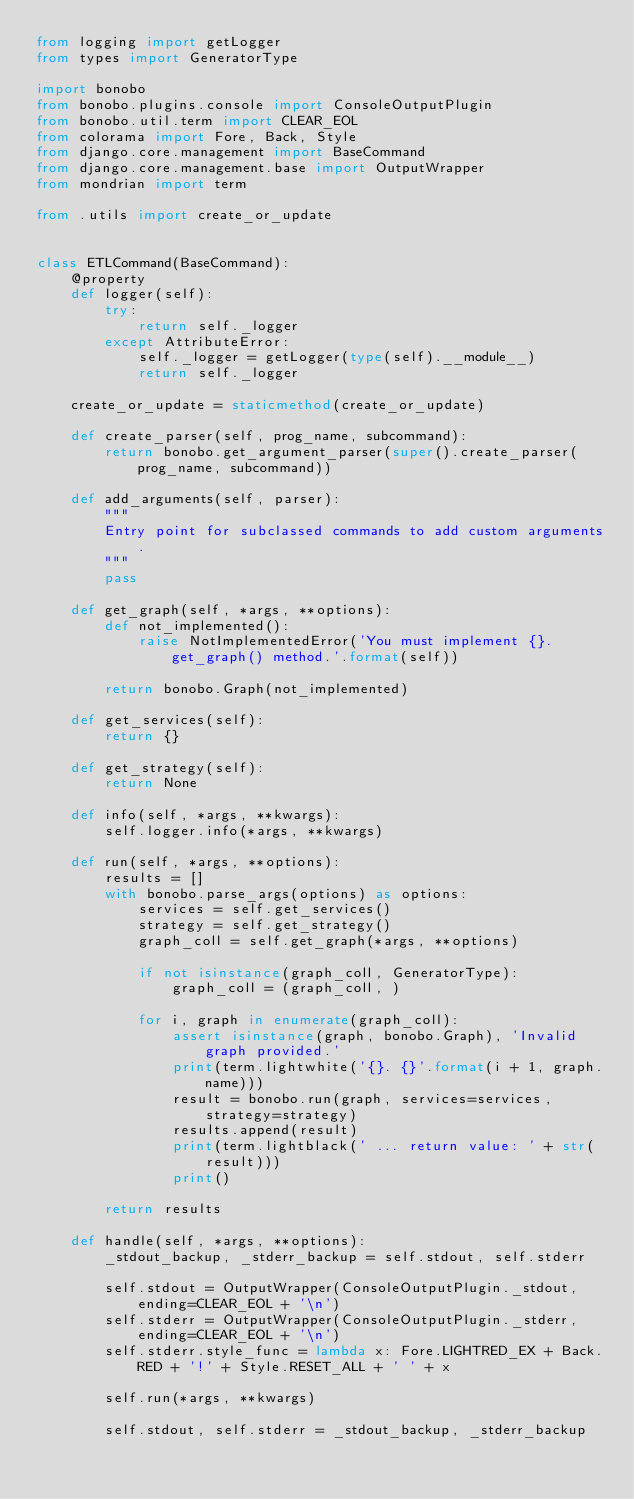<code> <loc_0><loc_0><loc_500><loc_500><_Python_>from logging import getLogger
from types import GeneratorType

import bonobo
from bonobo.plugins.console import ConsoleOutputPlugin
from bonobo.util.term import CLEAR_EOL
from colorama import Fore, Back, Style
from django.core.management import BaseCommand
from django.core.management.base import OutputWrapper
from mondrian import term

from .utils import create_or_update


class ETLCommand(BaseCommand):
    @property
    def logger(self):
        try:
            return self._logger
        except AttributeError:
            self._logger = getLogger(type(self).__module__)
            return self._logger

    create_or_update = staticmethod(create_or_update)

    def create_parser(self, prog_name, subcommand):
        return bonobo.get_argument_parser(super().create_parser(prog_name, subcommand))

    def add_arguments(self, parser):
        """
        Entry point for subclassed commands to add custom arguments.
        """
        pass

    def get_graph(self, *args, **options):
        def not_implemented():
            raise NotImplementedError('You must implement {}.get_graph() method.'.format(self))

        return bonobo.Graph(not_implemented)

    def get_services(self):
        return {}

    def get_strategy(self):
        return None

    def info(self, *args, **kwargs):
        self.logger.info(*args, **kwargs)

    def run(self, *args, **options):
        results = []
        with bonobo.parse_args(options) as options:
            services = self.get_services()
            strategy = self.get_strategy()
            graph_coll = self.get_graph(*args, **options)

            if not isinstance(graph_coll, GeneratorType):
                graph_coll = (graph_coll, )

            for i, graph in enumerate(graph_coll):
                assert isinstance(graph, bonobo.Graph), 'Invalid graph provided.'
                print(term.lightwhite('{}. {}'.format(i + 1, graph.name)))
                result = bonobo.run(graph, services=services, strategy=strategy)
                results.append(result)
                print(term.lightblack(' ... return value: ' + str(result)))
                print()

        return results

    def handle(self, *args, **options):
        _stdout_backup, _stderr_backup = self.stdout, self.stderr

        self.stdout = OutputWrapper(ConsoleOutputPlugin._stdout, ending=CLEAR_EOL + '\n')
        self.stderr = OutputWrapper(ConsoleOutputPlugin._stderr, ending=CLEAR_EOL + '\n')
        self.stderr.style_func = lambda x: Fore.LIGHTRED_EX + Back.RED + '!' + Style.RESET_ALL + ' ' + x

        self.run(*args, **kwargs)

        self.stdout, self.stderr = _stdout_backup, _stderr_backup
</code> 